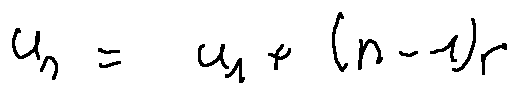Convert formula to latex. <formula><loc_0><loc_0><loc_500><loc_500>u _ { n } = u _ { 1 } + ( n - 1 ) r</formula> 